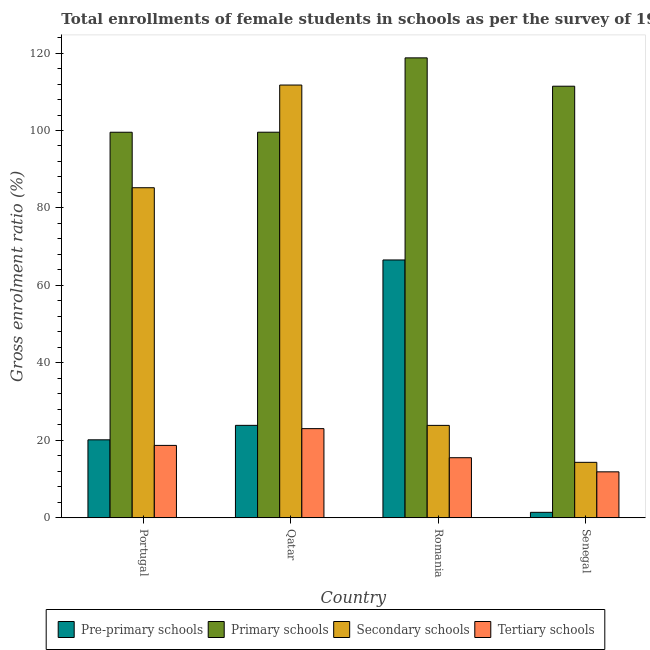How many different coloured bars are there?
Make the answer very short. 4. How many groups of bars are there?
Provide a short and direct response. 4. Are the number of bars per tick equal to the number of legend labels?
Offer a terse response. Yes. Are the number of bars on each tick of the X-axis equal?
Ensure brevity in your answer.  Yes. How many bars are there on the 1st tick from the left?
Make the answer very short. 4. What is the label of the 3rd group of bars from the left?
Your response must be concise. Romania. What is the gross enrolment ratio(female) in tertiary schools in Romania?
Keep it short and to the point. 15.5. Across all countries, what is the maximum gross enrolment ratio(female) in pre-primary schools?
Give a very brief answer. 66.57. Across all countries, what is the minimum gross enrolment ratio(female) in tertiary schools?
Your response must be concise. 11.86. In which country was the gross enrolment ratio(female) in secondary schools maximum?
Offer a terse response. Qatar. In which country was the gross enrolment ratio(female) in secondary schools minimum?
Offer a terse response. Senegal. What is the total gross enrolment ratio(female) in secondary schools in the graph?
Ensure brevity in your answer.  235.12. What is the difference between the gross enrolment ratio(female) in tertiary schools in Portugal and that in Qatar?
Give a very brief answer. -4.33. What is the difference between the gross enrolment ratio(female) in secondary schools in Senegal and the gross enrolment ratio(female) in primary schools in Romania?
Your answer should be very brief. -104.44. What is the average gross enrolment ratio(female) in primary schools per country?
Ensure brevity in your answer.  107.32. What is the difference between the gross enrolment ratio(female) in primary schools and gross enrolment ratio(female) in secondary schools in Portugal?
Your answer should be very brief. 14.32. In how many countries, is the gross enrolment ratio(female) in secondary schools greater than 40 %?
Offer a very short reply. 2. What is the ratio of the gross enrolment ratio(female) in tertiary schools in Qatar to that in Romania?
Provide a short and direct response. 1.48. Is the difference between the gross enrolment ratio(female) in tertiary schools in Qatar and Senegal greater than the difference between the gross enrolment ratio(female) in secondary schools in Qatar and Senegal?
Your response must be concise. No. What is the difference between the highest and the second highest gross enrolment ratio(female) in tertiary schools?
Ensure brevity in your answer.  4.33. What is the difference between the highest and the lowest gross enrolment ratio(female) in primary schools?
Give a very brief answer. 19.21. Is it the case that in every country, the sum of the gross enrolment ratio(female) in secondary schools and gross enrolment ratio(female) in primary schools is greater than the sum of gross enrolment ratio(female) in tertiary schools and gross enrolment ratio(female) in pre-primary schools?
Provide a short and direct response. No. What does the 1st bar from the left in Portugal represents?
Give a very brief answer. Pre-primary schools. What does the 1st bar from the right in Qatar represents?
Give a very brief answer. Tertiary schools. Is it the case that in every country, the sum of the gross enrolment ratio(female) in pre-primary schools and gross enrolment ratio(female) in primary schools is greater than the gross enrolment ratio(female) in secondary schools?
Your response must be concise. Yes. Are all the bars in the graph horizontal?
Your answer should be compact. No. How many countries are there in the graph?
Offer a very short reply. 4. Are the values on the major ticks of Y-axis written in scientific E-notation?
Your answer should be very brief. No. Does the graph contain grids?
Your response must be concise. No. Where does the legend appear in the graph?
Offer a very short reply. Bottom center. How many legend labels are there?
Make the answer very short. 4. How are the legend labels stacked?
Keep it short and to the point. Horizontal. What is the title of the graph?
Provide a short and direct response. Total enrollments of female students in schools as per the survey of 1981 conducted in different countries. Does "Minerals" appear as one of the legend labels in the graph?
Your answer should be compact. No. What is the label or title of the X-axis?
Offer a very short reply. Country. What is the label or title of the Y-axis?
Provide a succinct answer. Gross enrolment ratio (%). What is the Gross enrolment ratio (%) in Pre-primary schools in Portugal?
Offer a terse response. 20.12. What is the Gross enrolment ratio (%) of Primary schools in Portugal?
Give a very brief answer. 99.55. What is the Gross enrolment ratio (%) in Secondary schools in Portugal?
Your answer should be very brief. 85.22. What is the Gross enrolment ratio (%) of Tertiary schools in Portugal?
Keep it short and to the point. 18.68. What is the Gross enrolment ratio (%) of Pre-primary schools in Qatar?
Provide a succinct answer. 23.86. What is the Gross enrolment ratio (%) in Primary schools in Qatar?
Offer a terse response. 99.56. What is the Gross enrolment ratio (%) of Secondary schools in Qatar?
Give a very brief answer. 111.74. What is the Gross enrolment ratio (%) in Tertiary schools in Qatar?
Give a very brief answer. 23.01. What is the Gross enrolment ratio (%) in Pre-primary schools in Romania?
Give a very brief answer. 66.57. What is the Gross enrolment ratio (%) in Primary schools in Romania?
Provide a succinct answer. 118.75. What is the Gross enrolment ratio (%) in Secondary schools in Romania?
Keep it short and to the point. 23.85. What is the Gross enrolment ratio (%) of Tertiary schools in Romania?
Provide a succinct answer. 15.5. What is the Gross enrolment ratio (%) in Pre-primary schools in Senegal?
Give a very brief answer. 1.4. What is the Gross enrolment ratio (%) in Primary schools in Senegal?
Offer a terse response. 111.44. What is the Gross enrolment ratio (%) of Secondary schools in Senegal?
Offer a very short reply. 14.31. What is the Gross enrolment ratio (%) of Tertiary schools in Senegal?
Offer a terse response. 11.86. Across all countries, what is the maximum Gross enrolment ratio (%) in Pre-primary schools?
Give a very brief answer. 66.57. Across all countries, what is the maximum Gross enrolment ratio (%) in Primary schools?
Ensure brevity in your answer.  118.75. Across all countries, what is the maximum Gross enrolment ratio (%) of Secondary schools?
Your answer should be compact. 111.74. Across all countries, what is the maximum Gross enrolment ratio (%) of Tertiary schools?
Offer a very short reply. 23.01. Across all countries, what is the minimum Gross enrolment ratio (%) in Pre-primary schools?
Give a very brief answer. 1.4. Across all countries, what is the minimum Gross enrolment ratio (%) in Primary schools?
Your answer should be compact. 99.55. Across all countries, what is the minimum Gross enrolment ratio (%) in Secondary schools?
Provide a short and direct response. 14.31. Across all countries, what is the minimum Gross enrolment ratio (%) of Tertiary schools?
Provide a succinct answer. 11.86. What is the total Gross enrolment ratio (%) in Pre-primary schools in the graph?
Give a very brief answer. 111.96. What is the total Gross enrolment ratio (%) in Primary schools in the graph?
Make the answer very short. 429.3. What is the total Gross enrolment ratio (%) of Secondary schools in the graph?
Offer a very short reply. 235.12. What is the total Gross enrolment ratio (%) of Tertiary schools in the graph?
Your response must be concise. 69.06. What is the difference between the Gross enrolment ratio (%) in Pre-primary schools in Portugal and that in Qatar?
Provide a succinct answer. -3.74. What is the difference between the Gross enrolment ratio (%) in Primary schools in Portugal and that in Qatar?
Provide a succinct answer. -0.01. What is the difference between the Gross enrolment ratio (%) in Secondary schools in Portugal and that in Qatar?
Provide a succinct answer. -26.52. What is the difference between the Gross enrolment ratio (%) in Tertiary schools in Portugal and that in Qatar?
Offer a terse response. -4.33. What is the difference between the Gross enrolment ratio (%) in Pre-primary schools in Portugal and that in Romania?
Offer a terse response. -46.45. What is the difference between the Gross enrolment ratio (%) of Primary schools in Portugal and that in Romania?
Provide a succinct answer. -19.21. What is the difference between the Gross enrolment ratio (%) of Secondary schools in Portugal and that in Romania?
Your answer should be very brief. 61.37. What is the difference between the Gross enrolment ratio (%) of Tertiary schools in Portugal and that in Romania?
Offer a very short reply. 3.18. What is the difference between the Gross enrolment ratio (%) in Pre-primary schools in Portugal and that in Senegal?
Ensure brevity in your answer.  18.73. What is the difference between the Gross enrolment ratio (%) in Primary schools in Portugal and that in Senegal?
Make the answer very short. -11.89. What is the difference between the Gross enrolment ratio (%) in Secondary schools in Portugal and that in Senegal?
Make the answer very short. 70.91. What is the difference between the Gross enrolment ratio (%) of Tertiary schools in Portugal and that in Senegal?
Your answer should be very brief. 6.82. What is the difference between the Gross enrolment ratio (%) in Pre-primary schools in Qatar and that in Romania?
Your answer should be very brief. -42.71. What is the difference between the Gross enrolment ratio (%) of Primary schools in Qatar and that in Romania?
Make the answer very short. -19.2. What is the difference between the Gross enrolment ratio (%) of Secondary schools in Qatar and that in Romania?
Keep it short and to the point. 87.89. What is the difference between the Gross enrolment ratio (%) of Tertiary schools in Qatar and that in Romania?
Your response must be concise. 7.51. What is the difference between the Gross enrolment ratio (%) in Pre-primary schools in Qatar and that in Senegal?
Your answer should be compact. 22.46. What is the difference between the Gross enrolment ratio (%) of Primary schools in Qatar and that in Senegal?
Offer a terse response. -11.88. What is the difference between the Gross enrolment ratio (%) in Secondary schools in Qatar and that in Senegal?
Offer a terse response. 97.43. What is the difference between the Gross enrolment ratio (%) in Tertiary schools in Qatar and that in Senegal?
Provide a succinct answer. 11.15. What is the difference between the Gross enrolment ratio (%) in Pre-primary schools in Romania and that in Senegal?
Make the answer very short. 65.17. What is the difference between the Gross enrolment ratio (%) of Primary schools in Romania and that in Senegal?
Provide a succinct answer. 7.32. What is the difference between the Gross enrolment ratio (%) in Secondary schools in Romania and that in Senegal?
Your answer should be compact. 9.54. What is the difference between the Gross enrolment ratio (%) in Tertiary schools in Romania and that in Senegal?
Your response must be concise. 3.65. What is the difference between the Gross enrolment ratio (%) of Pre-primary schools in Portugal and the Gross enrolment ratio (%) of Primary schools in Qatar?
Offer a very short reply. -79.43. What is the difference between the Gross enrolment ratio (%) in Pre-primary schools in Portugal and the Gross enrolment ratio (%) in Secondary schools in Qatar?
Provide a short and direct response. -91.61. What is the difference between the Gross enrolment ratio (%) in Pre-primary schools in Portugal and the Gross enrolment ratio (%) in Tertiary schools in Qatar?
Your response must be concise. -2.89. What is the difference between the Gross enrolment ratio (%) of Primary schools in Portugal and the Gross enrolment ratio (%) of Secondary schools in Qatar?
Keep it short and to the point. -12.19. What is the difference between the Gross enrolment ratio (%) in Primary schools in Portugal and the Gross enrolment ratio (%) in Tertiary schools in Qatar?
Give a very brief answer. 76.54. What is the difference between the Gross enrolment ratio (%) in Secondary schools in Portugal and the Gross enrolment ratio (%) in Tertiary schools in Qatar?
Offer a terse response. 62.21. What is the difference between the Gross enrolment ratio (%) in Pre-primary schools in Portugal and the Gross enrolment ratio (%) in Primary schools in Romania?
Offer a terse response. -98.63. What is the difference between the Gross enrolment ratio (%) in Pre-primary schools in Portugal and the Gross enrolment ratio (%) in Secondary schools in Romania?
Your answer should be compact. -3.73. What is the difference between the Gross enrolment ratio (%) of Pre-primary schools in Portugal and the Gross enrolment ratio (%) of Tertiary schools in Romania?
Your answer should be very brief. 4.62. What is the difference between the Gross enrolment ratio (%) of Primary schools in Portugal and the Gross enrolment ratio (%) of Secondary schools in Romania?
Ensure brevity in your answer.  75.7. What is the difference between the Gross enrolment ratio (%) in Primary schools in Portugal and the Gross enrolment ratio (%) in Tertiary schools in Romania?
Ensure brevity in your answer.  84.04. What is the difference between the Gross enrolment ratio (%) of Secondary schools in Portugal and the Gross enrolment ratio (%) of Tertiary schools in Romania?
Your answer should be compact. 69.72. What is the difference between the Gross enrolment ratio (%) in Pre-primary schools in Portugal and the Gross enrolment ratio (%) in Primary schools in Senegal?
Offer a terse response. -91.31. What is the difference between the Gross enrolment ratio (%) in Pre-primary schools in Portugal and the Gross enrolment ratio (%) in Secondary schools in Senegal?
Keep it short and to the point. 5.81. What is the difference between the Gross enrolment ratio (%) of Pre-primary schools in Portugal and the Gross enrolment ratio (%) of Tertiary schools in Senegal?
Give a very brief answer. 8.27. What is the difference between the Gross enrolment ratio (%) of Primary schools in Portugal and the Gross enrolment ratio (%) of Secondary schools in Senegal?
Your answer should be very brief. 85.24. What is the difference between the Gross enrolment ratio (%) in Primary schools in Portugal and the Gross enrolment ratio (%) in Tertiary schools in Senegal?
Ensure brevity in your answer.  87.69. What is the difference between the Gross enrolment ratio (%) in Secondary schools in Portugal and the Gross enrolment ratio (%) in Tertiary schools in Senegal?
Offer a terse response. 73.36. What is the difference between the Gross enrolment ratio (%) in Pre-primary schools in Qatar and the Gross enrolment ratio (%) in Primary schools in Romania?
Provide a succinct answer. -94.89. What is the difference between the Gross enrolment ratio (%) in Pre-primary schools in Qatar and the Gross enrolment ratio (%) in Secondary schools in Romania?
Offer a very short reply. 0.01. What is the difference between the Gross enrolment ratio (%) in Pre-primary schools in Qatar and the Gross enrolment ratio (%) in Tertiary schools in Romania?
Offer a terse response. 8.36. What is the difference between the Gross enrolment ratio (%) of Primary schools in Qatar and the Gross enrolment ratio (%) of Secondary schools in Romania?
Offer a very short reply. 75.71. What is the difference between the Gross enrolment ratio (%) in Primary schools in Qatar and the Gross enrolment ratio (%) in Tertiary schools in Romania?
Provide a short and direct response. 84.05. What is the difference between the Gross enrolment ratio (%) of Secondary schools in Qatar and the Gross enrolment ratio (%) of Tertiary schools in Romania?
Your answer should be very brief. 96.24. What is the difference between the Gross enrolment ratio (%) in Pre-primary schools in Qatar and the Gross enrolment ratio (%) in Primary schools in Senegal?
Ensure brevity in your answer.  -87.57. What is the difference between the Gross enrolment ratio (%) in Pre-primary schools in Qatar and the Gross enrolment ratio (%) in Secondary schools in Senegal?
Ensure brevity in your answer.  9.55. What is the difference between the Gross enrolment ratio (%) in Pre-primary schools in Qatar and the Gross enrolment ratio (%) in Tertiary schools in Senegal?
Ensure brevity in your answer.  12. What is the difference between the Gross enrolment ratio (%) in Primary schools in Qatar and the Gross enrolment ratio (%) in Secondary schools in Senegal?
Your answer should be very brief. 85.25. What is the difference between the Gross enrolment ratio (%) in Primary schools in Qatar and the Gross enrolment ratio (%) in Tertiary schools in Senegal?
Your answer should be compact. 87.7. What is the difference between the Gross enrolment ratio (%) of Secondary schools in Qatar and the Gross enrolment ratio (%) of Tertiary schools in Senegal?
Your response must be concise. 99.88. What is the difference between the Gross enrolment ratio (%) in Pre-primary schools in Romania and the Gross enrolment ratio (%) in Primary schools in Senegal?
Provide a succinct answer. -44.87. What is the difference between the Gross enrolment ratio (%) in Pre-primary schools in Romania and the Gross enrolment ratio (%) in Secondary schools in Senegal?
Give a very brief answer. 52.26. What is the difference between the Gross enrolment ratio (%) of Pre-primary schools in Romania and the Gross enrolment ratio (%) of Tertiary schools in Senegal?
Your answer should be compact. 54.71. What is the difference between the Gross enrolment ratio (%) of Primary schools in Romania and the Gross enrolment ratio (%) of Secondary schools in Senegal?
Offer a very short reply. 104.44. What is the difference between the Gross enrolment ratio (%) of Primary schools in Romania and the Gross enrolment ratio (%) of Tertiary schools in Senegal?
Ensure brevity in your answer.  106.9. What is the difference between the Gross enrolment ratio (%) in Secondary schools in Romania and the Gross enrolment ratio (%) in Tertiary schools in Senegal?
Offer a very short reply. 11.99. What is the average Gross enrolment ratio (%) of Pre-primary schools per country?
Your answer should be compact. 27.99. What is the average Gross enrolment ratio (%) of Primary schools per country?
Your answer should be very brief. 107.32. What is the average Gross enrolment ratio (%) of Secondary schools per country?
Make the answer very short. 58.78. What is the average Gross enrolment ratio (%) of Tertiary schools per country?
Provide a succinct answer. 17.26. What is the difference between the Gross enrolment ratio (%) of Pre-primary schools and Gross enrolment ratio (%) of Primary schools in Portugal?
Provide a succinct answer. -79.42. What is the difference between the Gross enrolment ratio (%) in Pre-primary schools and Gross enrolment ratio (%) in Secondary schools in Portugal?
Your response must be concise. -65.1. What is the difference between the Gross enrolment ratio (%) in Pre-primary schools and Gross enrolment ratio (%) in Tertiary schools in Portugal?
Give a very brief answer. 1.44. What is the difference between the Gross enrolment ratio (%) in Primary schools and Gross enrolment ratio (%) in Secondary schools in Portugal?
Keep it short and to the point. 14.32. What is the difference between the Gross enrolment ratio (%) of Primary schools and Gross enrolment ratio (%) of Tertiary schools in Portugal?
Make the answer very short. 80.87. What is the difference between the Gross enrolment ratio (%) of Secondary schools and Gross enrolment ratio (%) of Tertiary schools in Portugal?
Offer a very short reply. 66.54. What is the difference between the Gross enrolment ratio (%) in Pre-primary schools and Gross enrolment ratio (%) in Primary schools in Qatar?
Provide a succinct answer. -75.69. What is the difference between the Gross enrolment ratio (%) in Pre-primary schools and Gross enrolment ratio (%) in Secondary schools in Qatar?
Give a very brief answer. -87.88. What is the difference between the Gross enrolment ratio (%) of Pre-primary schools and Gross enrolment ratio (%) of Tertiary schools in Qatar?
Your answer should be very brief. 0.85. What is the difference between the Gross enrolment ratio (%) in Primary schools and Gross enrolment ratio (%) in Secondary schools in Qatar?
Offer a very short reply. -12.18. What is the difference between the Gross enrolment ratio (%) in Primary schools and Gross enrolment ratio (%) in Tertiary schools in Qatar?
Make the answer very short. 76.54. What is the difference between the Gross enrolment ratio (%) in Secondary schools and Gross enrolment ratio (%) in Tertiary schools in Qatar?
Ensure brevity in your answer.  88.73. What is the difference between the Gross enrolment ratio (%) in Pre-primary schools and Gross enrolment ratio (%) in Primary schools in Romania?
Ensure brevity in your answer.  -52.18. What is the difference between the Gross enrolment ratio (%) of Pre-primary schools and Gross enrolment ratio (%) of Secondary schools in Romania?
Offer a terse response. 42.72. What is the difference between the Gross enrolment ratio (%) in Pre-primary schools and Gross enrolment ratio (%) in Tertiary schools in Romania?
Your answer should be compact. 51.07. What is the difference between the Gross enrolment ratio (%) in Primary schools and Gross enrolment ratio (%) in Secondary schools in Romania?
Ensure brevity in your answer.  94.9. What is the difference between the Gross enrolment ratio (%) in Primary schools and Gross enrolment ratio (%) in Tertiary schools in Romania?
Keep it short and to the point. 103.25. What is the difference between the Gross enrolment ratio (%) of Secondary schools and Gross enrolment ratio (%) of Tertiary schools in Romania?
Provide a succinct answer. 8.35. What is the difference between the Gross enrolment ratio (%) in Pre-primary schools and Gross enrolment ratio (%) in Primary schools in Senegal?
Your response must be concise. -110.04. What is the difference between the Gross enrolment ratio (%) in Pre-primary schools and Gross enrolment ratio (%) in Secondary schools in Senegal?
Give a very brief answer. -12.91. What is the difference between the Gross enrolment ratio (%) of Pre-primary schools and Gross enrolment ratio (%) of Tertiary schools in Senegal?
Make the answer very short. -10.46. What is the difference between the Gross enrolment ratio (%) of Primary schools and Gross enrolment ratio (%) of Secondary schools in Senegal?
Ensure brevity in your answer.  97.13. What is the difference between the Gross enrolment ratio (%) of Primary schools and Gross enrolment ratio (%) of Tertiary schools in Senegal?
Your response must be concise. 99.58. What is the difference between the Gross enrolment ratio (%) in Secondary schools and Gross enrolment ratio (%) in Tertiary schools in Senegal?
Your answer should be very brief. 2.45. What is the ratio of the Gross enrolment ratio (%) of Pre-primary schools in Portugal to that in Qatar?
Your answer should be very brief. 0.84. What is the ratio of the Gross enrolment ratio (%) in Secondary schools in Portugal to that in Qatar?
Keep it short and to the point. 0.76. What is the ratio of the Gross enrolment ratio (%) in Tertiary schools in Portugal to that in Qatar?
Your answer should be very brief. 0.81. What is the ratio of the Gross enrolment ratio (%) of Pre-primary schools in Portugal to that in Romania?
Provide a short and direct response. 0.3. What is the ratio of the Gross enrolment ratio (%) of Primary schools in Portugal to that in Romania?
Ensure brevity in your answer.  0.84. What is the ratio of the Gross enrolment ratio (%) of Secondary schools in Portugal to that in Romania?
Your answer should be very brief. 3.57. What is the ratio of the Gross enrolment ratio (%) of Tertiary schools in Portugal to that in Romania?
Offer a very short reply. 1.21. What is the ratio of the Gross enrolment ratio (%) in Pre-primary schools in Portugal to that in Senegal?
Ensure brevity in your answer.  14.39. What is the ratio of the Gross enrolment ratio (%) of Primary schools in Portugal to that in Senegal?
Ensure brevity in your answer.  0.89. What is the ratio of the Gross enrolment ratio (%) of Secondary schools in Portugal to that in Senegal?
Your response must be concise. 5.96. What is the ratio of the Gross enrolment ratio (%) in Tertiary schools in Portugal to that in Senegal?
Your answer should be very brief. 1.58. What is the ratio of the Gross enrolment ratio (%) of Pre-primary schools in Qatar to that in Romania?
Offer a very short reply. 0.36. What is the ratio of the Gross enrolment ratio (%) in Primary schools in Qatar to that in Romania?
Give a very brief answer. 0.84. What is the ratio of the Gross enrolment ratio (%) of Secondary schools in Qatar to that in Romania?
Your answer should be very brief. 4.68. What is the ratio of the Gross enrolment ratio (%) in Tertiary schools in Qatar to that in Romania?
Keep it short and to the point. 1.48. What is the ratio of the Gross enrolment ratio (%) of Pre-primary schools in Qatar to that in Senegal?
Give a very brief answer. 17.06. What is the ratio of the Gross enrolment ratio (%) in Primary schools in Qatar to that in Senegal?
Offer a terse response. 0.89. What is the ratio of the Gross enrolment ratio (%) of Secondary schools in Qatar to that in Senegal?
Make the answer very short. 7.81. What is the ratio of the Gross enrolment ratio (%) of Tertiary schools in Qatar to that in Senegal?
Provide a short and direct response. 1.94. What is the ratio of the Gross enrolment ratio (%) in Pre-primary schools in Romania to that in Senegal?
Keep it short and to the point. 47.58. What is the ratio of the Gross enrolment ratio (%) of Primary schools in Romania to that in Senegal?
Ensure brevity in your answer.  1.07. What is the ratio of the Gross enrolment ratio (%) of Tertiary schools in Romania to that in Senegal?
Make the answer very short. 1.31. What is the difference between the highest and the second highest Gross enrolment ratio (%) in Pre-primary schools?
Offer a terse response. 42.71. What is the difference between the highest and the second highest Gross enrolment ratio (%) in Primary schools?
Your answer should be very brief. 7.32. What is the difference between the highest and the second highest Gross enrolment ratio (%) of Secondary schools?
Your answer should be compact. 26.52. What is the difference between the highest and the second highest Gross enrolment ratio (%) in Tertiary schools?
Offer a terse response. 4.33. What is the difference between the highest and the lowest Gross enrolment ratio (%) in Pre-primary schools?
Offer a very short reply. 65.17. What is the difference between the highest and the lowest Gross enrolment ratio (%) in Primary schools?
Provide a succinct answer. 19.21. What is the difference between the highest and the lowest Gross enrolment ratio (%) of Secondary schools?
Ensure brevity in your answer.  97.43. What is the difference between the highest and the lowest Gross enrolment ratio (%) of Tertiary schools?
Offer a terse response. 11.15. 